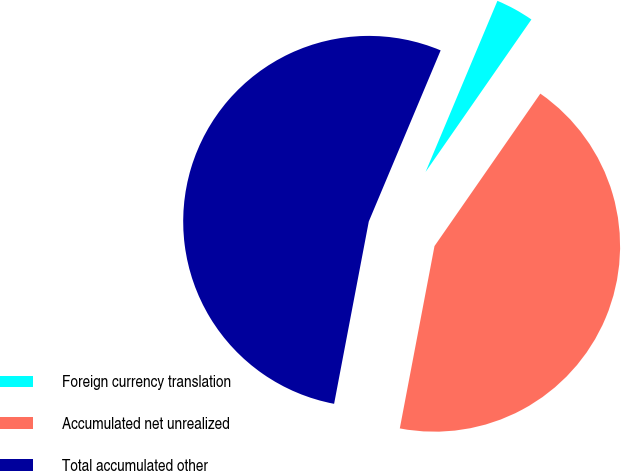Convert chart to OTSL. <chart><loc_0><loc_0><loc_500><loc_500><pie_chart><fcel>Foreign currency translation<fcel>Accumulated net unrealized<fcel>Total accumulated other<nl><fcel>3.33%<fcel>43.33%<fcel>53.33%<nl></chart> 